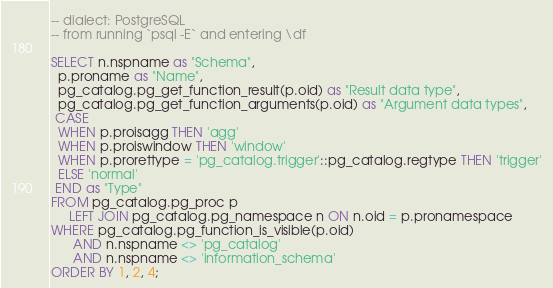Convert code to text. <code><loc_0><loc_0><loc_500><loc_500><_SQL_>-- dialect: PostgreSQL
-- from running `psql -E` and entering \df

SELECT n.nspname as "Schema",
  p.proname as "Name",
  pg_catalog.pg_get_function_result(p.oid) as "Result data type",
  pg_catalog.pg_get_function_arguments(p.oid) as "Argument data types",
 CASE
  WHEN p.proisagg THEN 'agg'
  WHEN p.proiswindow THEN 'window'
  WHEN p.prorettype = 'pg_catalog.trigger'::pg_catalog.regtype THEN 'trigger'
  ELSE 'normal'
 END as "Type"
FROM pg_catalog.pg_proc p
     LEFT JOIN pg_catalog.pg_namespace n ON n.oid = p.pronamespace
WHERE pg_catalog.pg_function_is_visible(p.oid)
      AND n.nspname <> 'pg_catalog'
      AND n.nspname <> 'information_schema'
ORDER BY 1, 2, 4;
</code> 